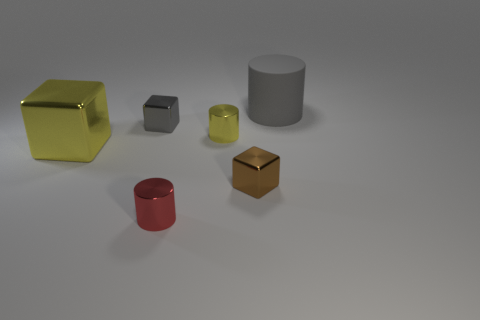Can you describe the lighting and potential mood of this scene? The lighting in the image appears soft and diffused, coming from an overhead source that casts gentle shadows behind each object. The mood could be described as calm and neutral, with a focus on the thoughtful arrangement of the objects and the subtle interplay of light and shadow, which adds depth to the scene without creating a dramatic effect. 